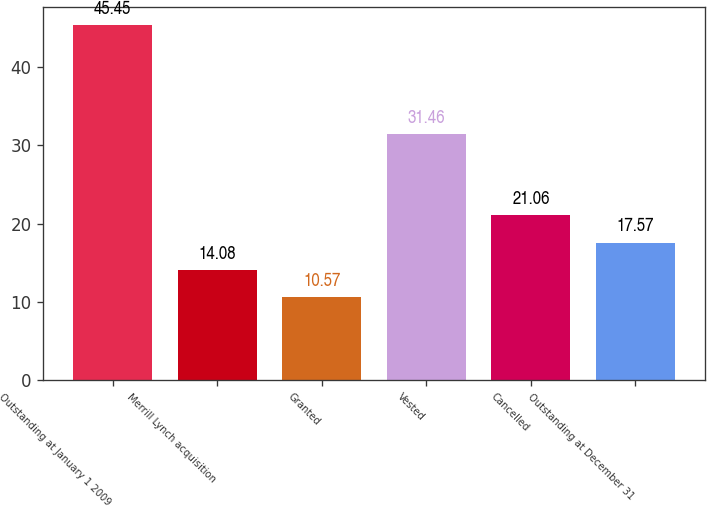Convert chart. <chart><loc_0><loc_0><loc_500><loc_500><bar_chart><fcel>Outstanding at January 1 2009<fcel>Merrill Lynch acquisition<fcel>Granted<fcel>Vested<fcel>Cancelled<fcel>Outstanding at December 31<nl><fcel>45.45<fcel>14.08<fcel>10.57<fcel>31.46<fcel>21.06<fcel>17.57<nl></chart> 